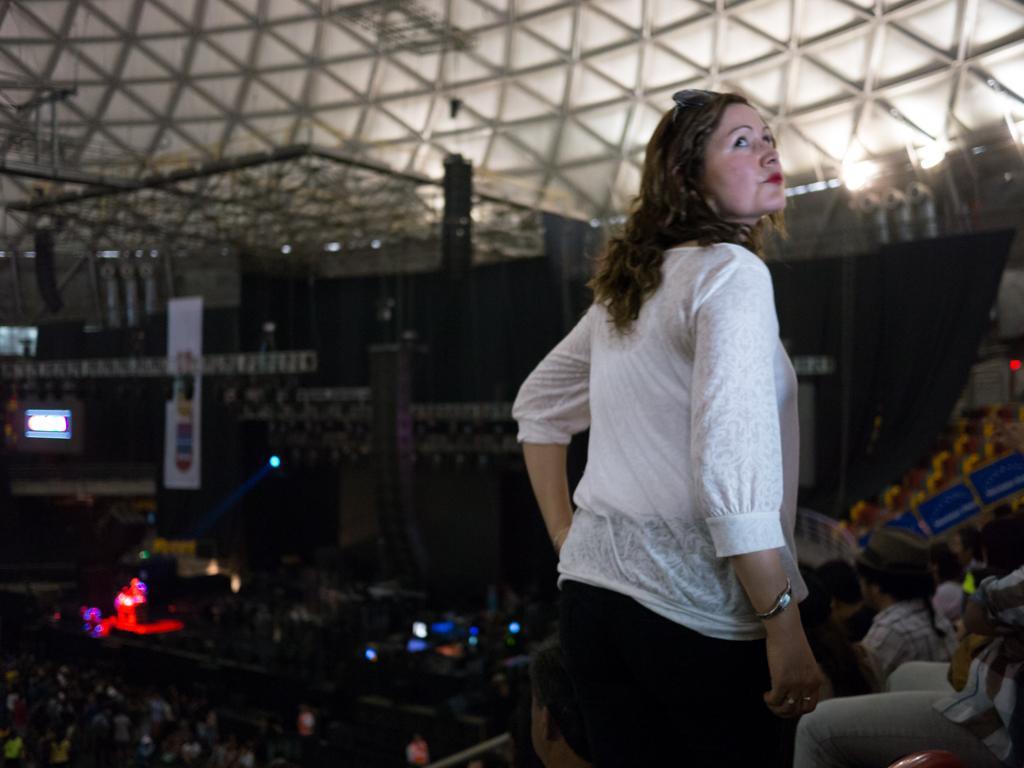How would you summarize this image in a sentence or two? In this picture we can see a woman is standing in the front, there are some people sitting on the right side, in the background there is a hoarding, a screen and a light, there is a blurry background. 